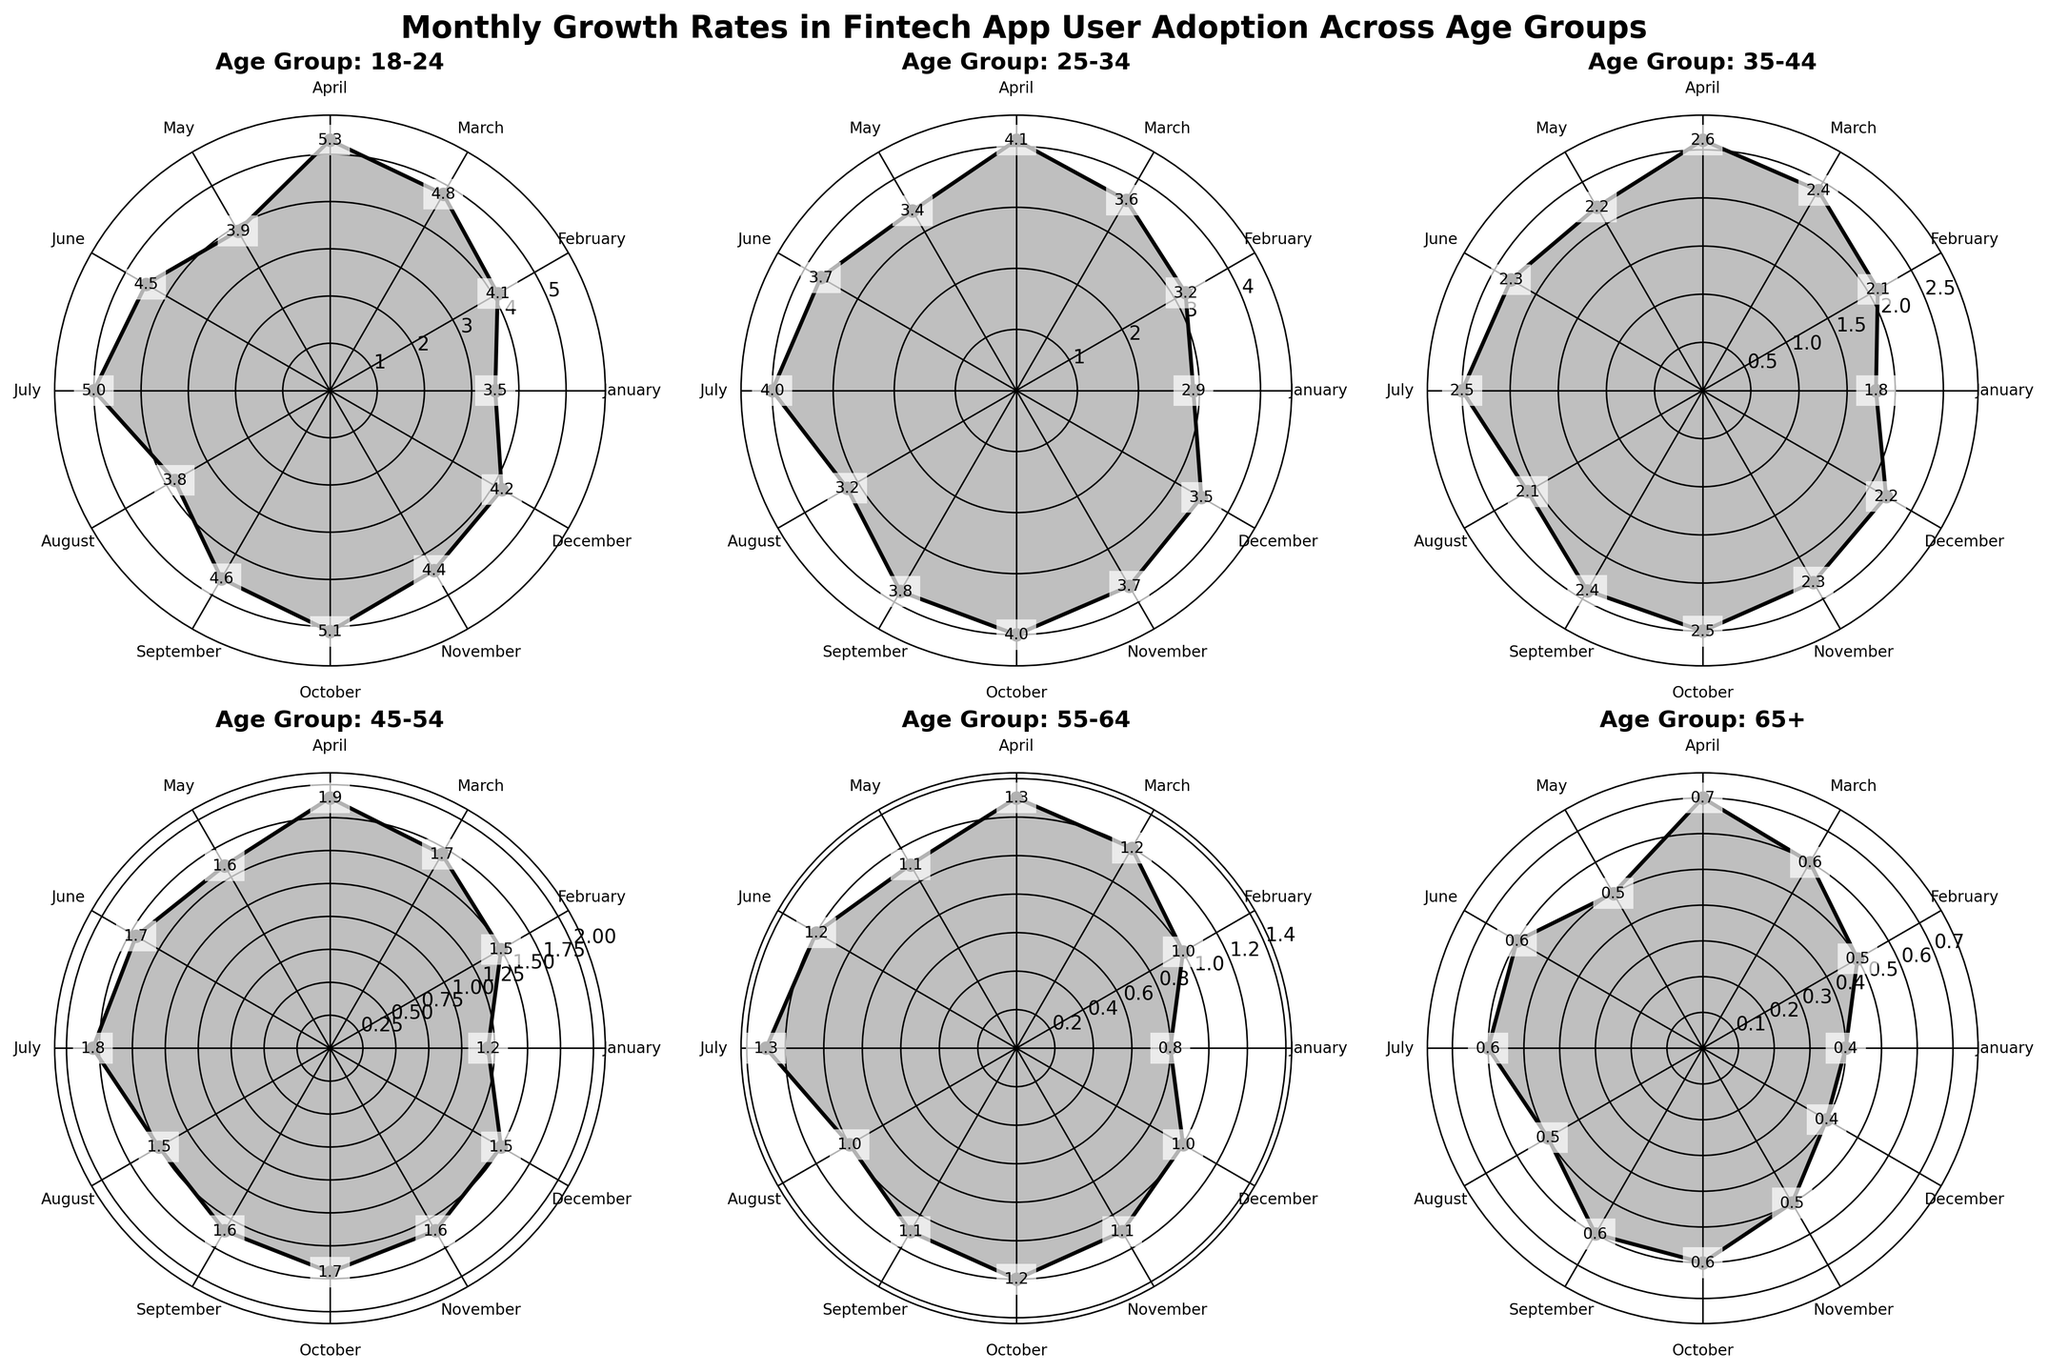Which age group has the highest growth rate in April? By looking at the plot for each age group, we can see that the 18-24 age group has the highest value in April.
Answer: 18-24 Which month shows the maximum growth rate for the 25-34 age group? By observing the 25-34 age group subplot, the month with the highest value is October.
Answer: October What is the average growth rate of user adoption for the 45-54 age group throughout the year? Sum the monthly growth rates for the 45-54 age group and divide by 12: (1.2 + 1.5 + 1.7 + 1.9 + 1.6 + 1.7 + 1.8 + 1.5 + 1.6 + 1.7 + 1.6 + 1.5)/12 = 1.6
Answer: 1.6 Is there any month with equal growth rates between two different age groups? Compare monthly growth rates across the subplots. Both the 55-64 and 65+ age groups have a growth rate of 1.2 in June.
Answer: Yes, June Which age group shows the most consistent (least variable) growth rate throughout the year? Calculate the range (max - min) of growth rates for each age group. The age group 65+ has the smallest range: (0.7 - 0.4) = 0.3
Answer: 65+ How does the average growth rate in December for all age groups compare to the overall average growth rate? Average December rates: (4.2 + 3.5 + 2.2 + 1.5 + 1.0 + 0.4)/6 = 2.13. Overall average: (sum of all values)/(6 age groups * 12 months) = 2.35.
Answer: Lower, 2.13 vs 2.35 Which age group demonstrates the highest drop in growth rate between consecutive months? By observing the plots, the 18-24 age group has the largest drop between April (5.3) and May (3.9), a difference of 1.4.
Answer: 18-24 Do any age groups have two months with the same growth rate within the same year? By checking the growth rates within each subplot, the 45-54 age group has the same growth rate of 1.5 in both February and August.
Answer: Yes, 45-54 Which age group saw the highest peak in any month, and what was the value? By looking at the plots, the 18-24 age group has the highest peak with a value of 5.3 in April.
Answer: 18-24, 5.3 